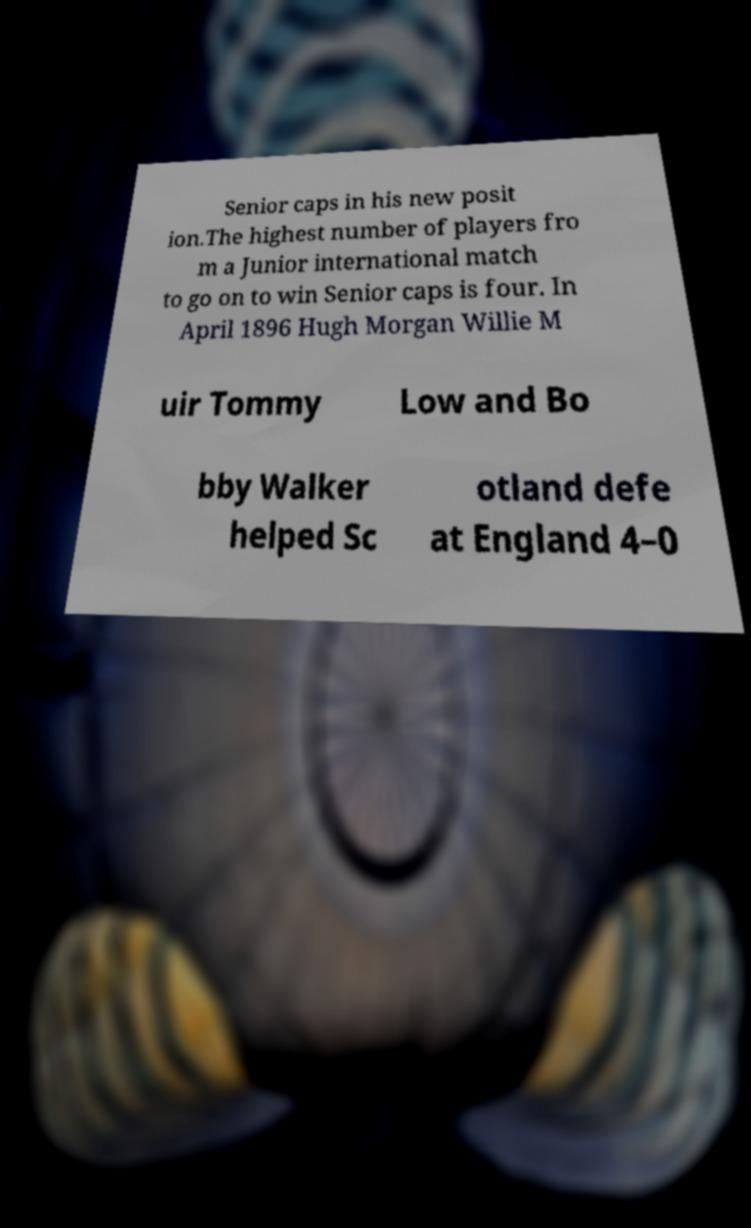Can you read and provide the text displayed in the image?This photo seems to have some interesting text. Can you extract and type it out for me? Senior caps in his new posit ion.The highest number of players fro m a Junior international match to go on to win Senior caps is four. In April 1896 Hugh Morgan Willie M uir Tommy Low and Bo bby Walker helped Sc otland defe at England 4–0 